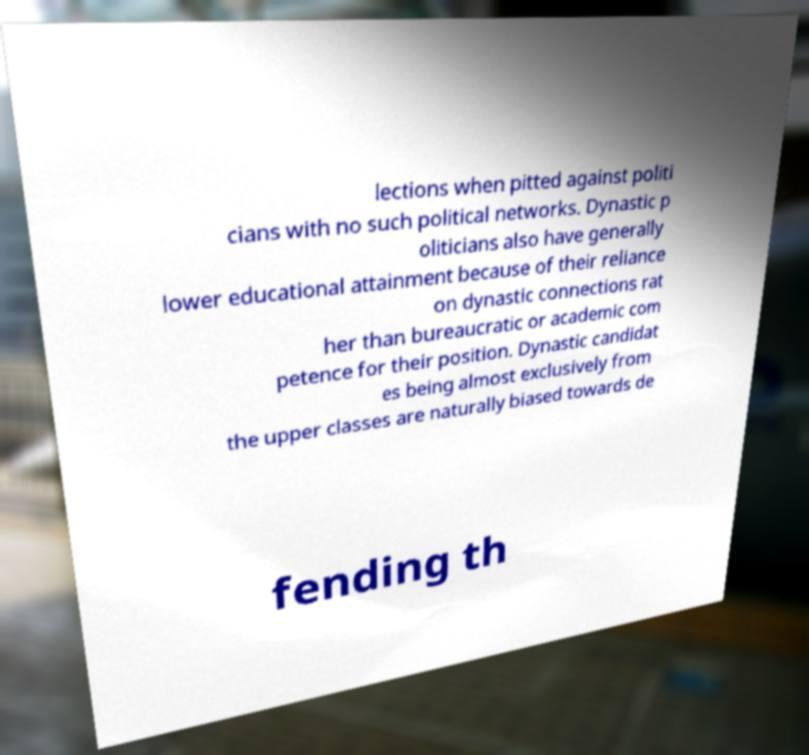Please identify and transcribe the text found in this image. lections when pitted against politi cians with no such political networks. Dynastic p oliticians also have generally lower educational attainment because of their reliance on dynastic connections rat her than bureaucratic or academic com petence for their position. Dynastic candidat es being almost exclusively from the upper classes are naturally biased towards de fending th 